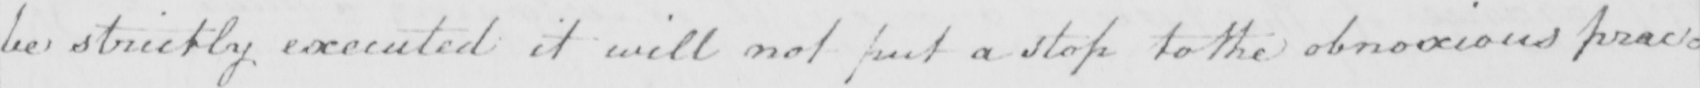Transcribe the text shown in this historical manuscript line. be strictly executed it will not put a stop to the obnoxious prac= 